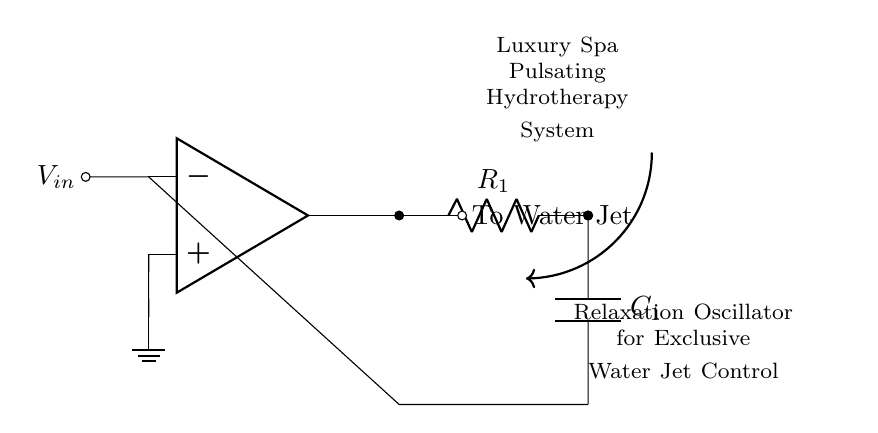What is the main function of this circuit? The main function of this circuit is to generate an oscillating signal that controls the pulsating water jets. This is achieved through the relaxation oscillator configuration, which uses an operational amplifier in conjunction with a resistor and a capacitor.
Answer: relaxation oscillator What components are used in this circuit? The components used in this circuit are an operational amplifier, a resistor labeled R1, and a capacitor labeled C1. Each component plays a crucial role in the timing and control of the oscillation frequency.
Answer: operational amplifier, resistor R1, capacitor C1 What does the output connect to? The output connects to the water jet system of the hydrotherapy setup. This output directs the pulsating signal generated by the oscillator to control water flow effectively.
Answer: To Water Jet How does the capacitor affect the oscillation frequency? The capacitor, in conjunction with the resistor, determines the charging and discharging time in the oscillator circuit, which influences the oscillation frequency. A larger capacitor will generally lead to a lower frequency and vice versa.
Answer: Influences frequency What type of oscillator is represented in the diagram? The type of oscillator represented in the diagram is a relaxation oscillator. This specific type of oscillator includes a feedback loop through the capacitor and uses the operational amplifier to create the oscillation.
Answer: relaxation oscillator What happens when the voltage input is increased? When the voltage input is increased, the rate of charge on the capacitor changes, which can lead to an increase in the frequency of the oscillation, resulting in faster pulsating water jets.
Answer: Increases frequency 